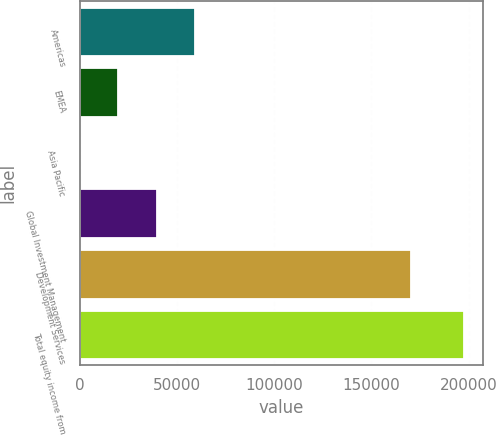<chart> <loc_0><loc_0><loc_500><loc_500><bar_chart><fcel>Americas<fcel>EMEA<fcel>Asia Pacific<fcel>Global Investment Management<fcel>Development Services<fcel>Total equity income from<nl><fcel>59361.4<fcel>19935.8<fcel>223<fcel>39648.6<fcel>170176<fcel>197351<nl></chart> 